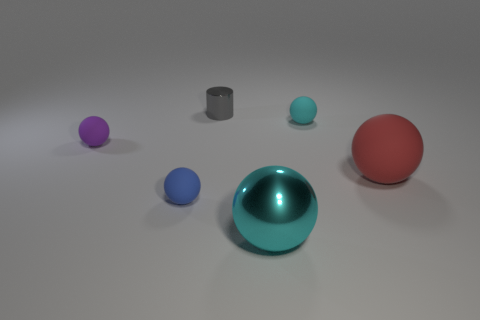Subtract all large cyan balls. How many balls are left? 4 Subtract all blue blocks. How many cyan balls are left? 2 Subtract all red balls. How many balls are left? 4 Add 1 large cyan shiny blocks. How many objects exist? 7 Subtract all blue spheres. Subtract all yellow cubes. How many spheres are left? 4 Subtract all cylinders. How many objects are left? 5 Subtract 1 purple balls. How many objects are left? 5 Subtract all tiny cyan rubber spheres. Subtract all rubber objects. How many objects are left? 1 Add 5 shiny objects. How many shiny objects are left? 7 Add 6 small cyan rubber objects. How many small cyan rubber objects exist? 7 